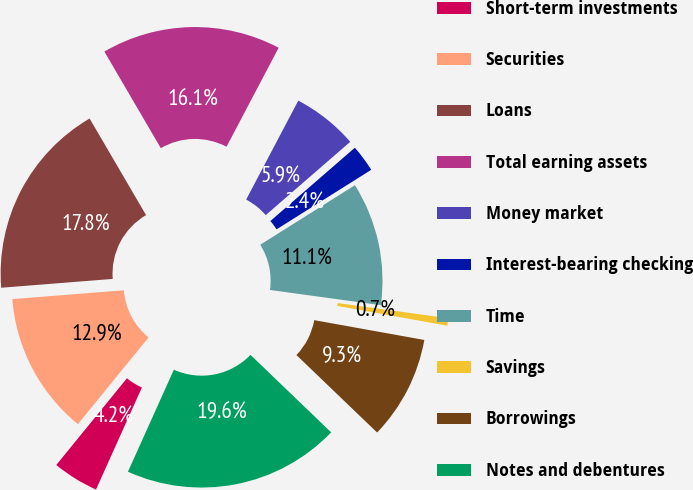<chart> <loc_0><loc_0><loc_500><loc_500><pie_chart><fcel>Short-term investments<fcel>Securities<fcel>Loans<fcel>Total earning assets<fcel>Money market<fcel>Interest-bearing checking<fcel>Time<fcel>Savings<fcel>Borrowings<fcel>Notes and debentures<nl><fcel>4.15%<fcel>12.86%<fcel>17.84%<fcel>16.13%<fcel>5.91%<fcel>2.44%<fcel>11.1%<fcel>0.67%<fcel>9.34%<fcel>19.55%<nl></chart> 